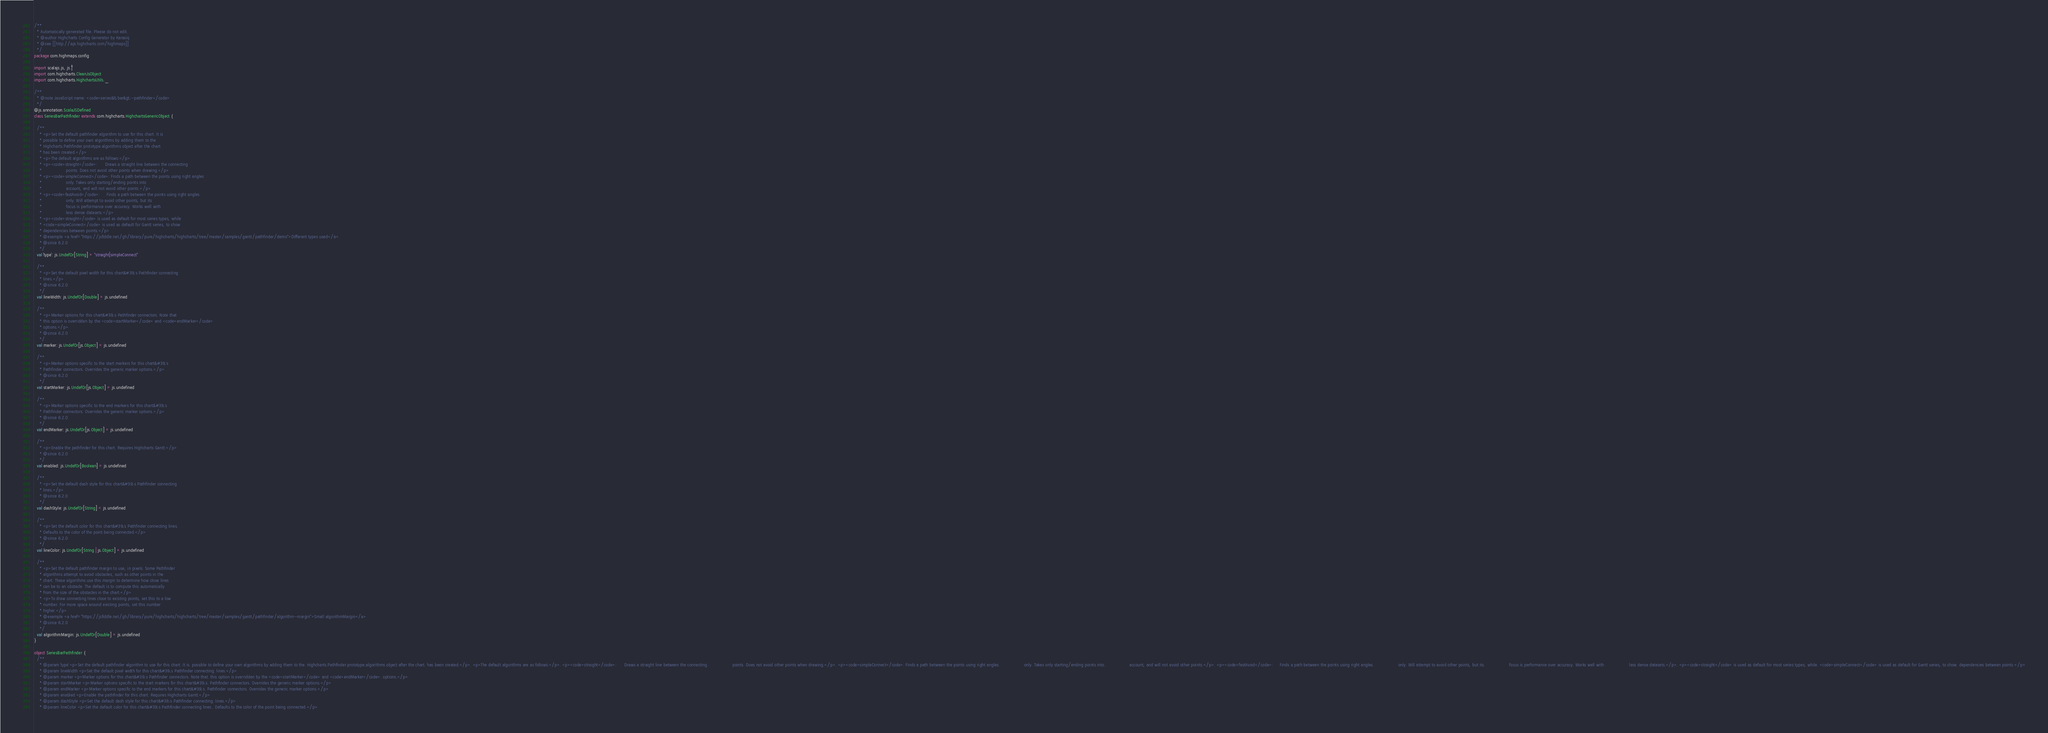Convert code to text. <code><loc_0><loc_0><loc_500><loc_500><_Scala_>/**
  * Automatically generated file. Please do not edit.
  * @author Highcharts Config Generator by Karasiq
  * @see [[http://api.highcharts.com/highmaps]]
  */
package com.highmaps.config

import scalajs.js, js.`|`
import com.highcharts.CleanJsObject
import com.highcharts.HighchartsUtils._

/**
  * @note JavaScript name: <code>series&lt;bar&gt;-pathfinder</code>
  */
@js.annotation.ScalaJSDefined
class SeriesBarPathfinder extends com.highcharts.HighchartsGenericObject {

  /**
    * <p>Set the default pathfinder algorithm to use for this chart. It is
    * possible to define your own algorithms by adding them to the
    * Highcharts.Pathfinder.prototype.algorithms object after the chart
    * has been created.</p>
    * <p>The default algorithms are as follows:</p>
    * <p><code>straight</code>:      Draws a straight line between the connecting
    *                  points. Does not avoid other points when drawing.</p>
    * <p><code>simpleConnect</code>: Finds a path between the points using right angles
    *                  only. Takes only starting/ending points into
    *                  account, and will not avoid other points.</p>
    * <p><code>fastAvoid</code>:     Finds a path between the points using right angles
    *                  only. Will attempt to avoid other points, but its
    *                  focus is performance over accuracy. Works well with
    *                  less dense datasets.</p>
    * <p><code>straight</code> is used as default for most series types, while
    * <code>simpleConnect</code> is used as default for Gantt series, to show
    * dependencies between points.</p>
    * @example <a href="https://jsfiddle.net/gh/library/pure/highcharts/highcharts/tree/master/samples/gantt/pathfinder/demo">Different types used</a>
    * @since 6.2.0
    */
  val `type`: js.UndefOr[String] = "straight|simpleConnect"

  /**
    * <p>Set the default pixel width for this chart&#39;s Pathfinder connecting
    * lines.</p>
    * @since 6.2.0
    */
  val lineWidth: js.UndefOr[Double] = js.undefined

  /**
    * <p>Marker options for this chart&#39;s Pathfinder connectors. Note that
    * this option is overridden by the <code>startMarker</code> and <code>endMarker</code>
    * options.</p>
    * @since 6.2.0
    */
  val marker: js.UndefOr[js.Object] = js.undefined

  /**
    * <p>Marker options specific to the start markers for this chart&#39;s
    * Pathfinder connectors. Overrides the generic marker options.</p>
    * @since 6.2.0
    */
  val startMarker: js.UndefOr[js.Object] = js.undefined

  /**
    * <p>Marker options specific to the end markers for this chart&#39;s
    * Pathfinder connectors. Overrides the generic marker options.</p>
    * @since 6.2.0
    */
  val endMarker: js.UndefOr[js.Object] = js.undefined

  /**
    * <p>Enable the pathfinder for this chart. Requires Highcharts Gantt.</p>
    * @since 6.2.0
    */
  val enabled: js.UndefOr[Boolean] = js.undefined

  /**
    * <p>Set the default dash style for this chart&#39;s Pathfinder connecting
    * lines.</p>
    * @since 6.2.0
    */
  val dashStyle: js.UndefOr[String] = js.undefined

  /**
    * <p>Set the default color for this chart&#39;s Pathfinder connecting lines.
    * Defaults to the color of the point being connected.</p>
    * @since 6.2.0
    */
  val lineColor: js.UndefOr[String | js.Object] = js.undefined

  /**
    * <p>Set the default pathfinder margin to use, in pixels. Some Pathfinder
    * algorithms attempt to avoid obstacles, such as other points in the
    * chart. These algorithms use this margin to determine how close lines
    * can be to an obstacle. The default is to compute this automatically
    * from the size of the obstacles in the chart.</p>
    * <p>To draw connecting lines close to existing points, set this to a low
    * number. For more space around existing points, set this number
    * higher.</p>
    * @example <a href="https://jsfiddle.net/gh/library/pure/highcharts/highcharts/tree/master/samples/gantt/pathfinder/algorithm-margin">Small algorithmMargin</a>
    * @since 6.2.0
    */
  val algorithmMargin: js.UndefOr[Double] = js.undefined
}

object SeriesBarPathfinder {
  /**
    * @param `type` <p>Set the default pathfinder algorithm to use for this chart. It is. possible to define your own algorithms by adding them to the. Highcharts.Pathfinder.prototype.algorithms object after the chart. has been created.</p>. <p>The default algorithms are as follows:</p>. <p><code>straight</code>:      Draws a straight line between the connecting.                  points. Does not avoid other points when drawing.</p>. <p><code>simpleConnect</code>: Finds a path between the points using right angles.                  only. Takes only starting/ending points into.                  account, and will not avoid other points.</p>. <p><code>fastAvoid</code>:     Finds a path between the points using right angles.                  only. Will attempt to avoid other points, but its.                  focus is performance over accuracy. Works well with.                  less dense datasets.</p>. <p><code>straight</code> is used as default for most series types, while. <code>simpleConnect</code> is used as default for Gantt series, to show. dependencies between points.</p>
    * @param lineWidth <p>Set the default pixel width for this chart&#39;s Pathfinder connecting. lines.</p>
    * @param marker <p>Marker options for this chart&#39;s Pathfinder connectors. Note that. this option is overridden by the <code>startMarker</code> and <code>endMarker</code>. options.</p>
    * @param startMarker <p>Marker options specific to the start markers for this chart&#39;s. Pathfinder connectors. Overrides the generic marker options.</p>
    * @param endMarker <p>Marker options specific to the end markers for this chart&#39;s. Pathfinder connectors. Overrides the generic marker options.</p>
    * @param enabled <p>Enable the pathfinder for this chart. Requires Highcharts Gantt.</p>
    * @param dashStyle <p>Set the default dash style for this chart&#39;s Pathfinder connecting. lines.</p>
    * @param lineColor <p>Set the default color for this chart&#39;s Pathfinder connecting lines.. Defaults to the color of the point being connected.</p></code> 